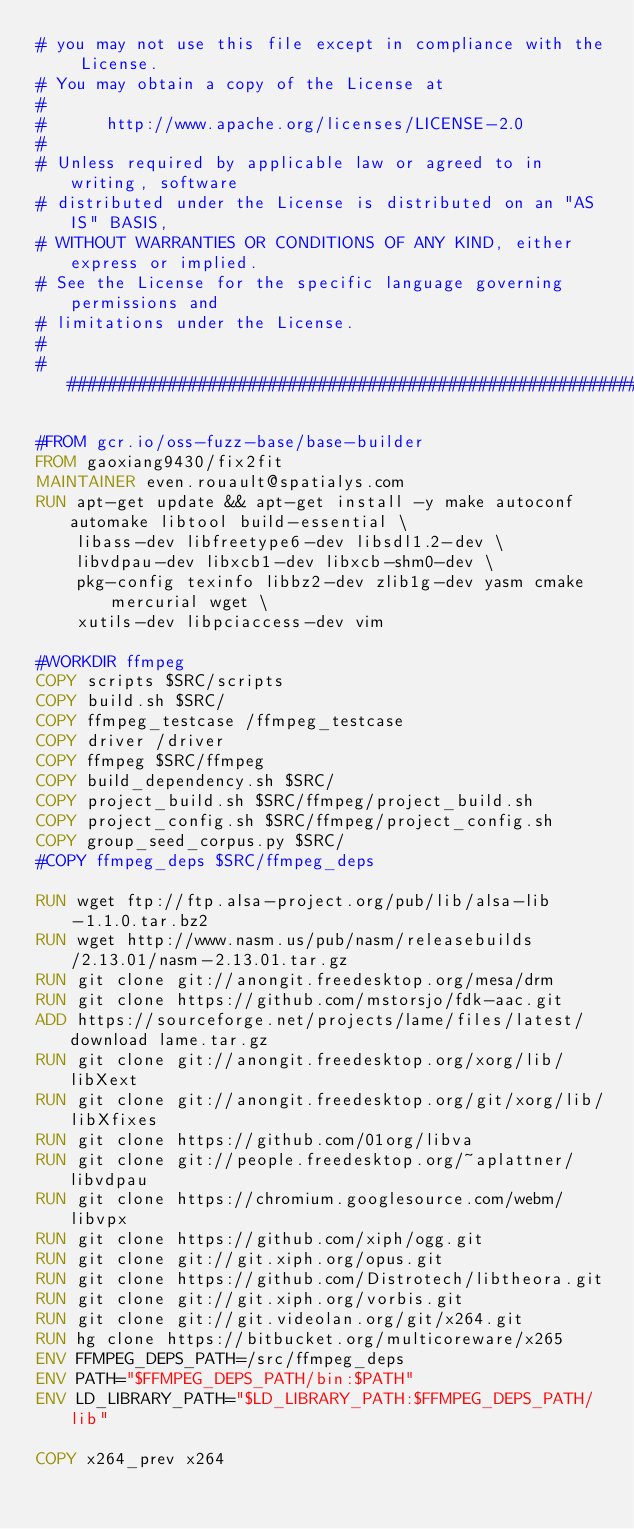Convert code to text. <code><loc_0><loc_0><loc_500><loc_500><_Dockerfile_># you may not use this file except in compliance with the License.
# You may obtain a copy of the License at
#
#      http://www.apache.org/licenses/LICENSE-2.0
#
# Unless required by applicable law or agreed to in writing, software
# distributed under the License is distributed on an "AS IS" BASIS,
# WITHOUT WARRANTIES OR CONDITIONS OF ANY KIND, either express or implied.
# See the License for the specific language governing permissions and
# limitations under the License.
#
################################################################################

#FROM gcr.io/oss-fuzz-base/base-builder
FROM gaoxiang9430/fix2fit
MAINTAINER even.rouault@spatialys.com
RUN apt-get update && apt-get install -y make autoconf automake libtool build-essential \
    libass-dev libfreetype6-dev libsdl1.2-dev \
    libvdpau-dev libxcb1-dev libxcb-shm0-dev \
    pkg-config texinfo libbz2-dev zlib1g-dev yasm cmake mercurial wget \
    xutils-dev libpciaccess-dev vim

#WORKDIR ffmpeg
COPY scripts $SRC/scripts
COPY build.sh $SRC/
COPY ffmpeg_testcase /ffmpeg_testcase
COPY driver /driver
COPY ffmpeg $SRC/ffmpeg
COPY build_dependency.sh $SRC/
COPY project_build.sh $SRC/ffmpeg/project_build.sh
COPY project_config.sh $SRC/ffmpeg/project_config.sh
COPY group_seed_corpus.py $SRC/
#COPY ffmpeg_deps $SRC/ffmpeg_deps

RUN wget ftp://ftp.alsa-project.org/pub/lib/alsa-lib-1.1.0.tar.bz2
RUN wget http://www.nasm.us/pub/nasm/releasebuilds/2.13.01/nasm-2.13.01.tar.gz
RUN git clone git://anongit.freedesktop.org/mesa/drm
RUN git clone https://github.com/mstorsjo/fdk-aac.git
ADD https://sourceforge.net/projects/lame/files/latest/download lame.tar.gz
RUN git clone git://anongit.freedesktop.org/xorg/lib/libXext
RUN git clone git://anongit.freedesktop.org/git/xorg/lib/libXfixes
RUN git clone https://github.com/01org/libva
RUN git clone git://people.freedesktop.org/~aplattner/libvdpau
RUN git clone https://chromium.googlesource.com/webm/libvpx
RUN git clone https://github.com/xiph/ogg.git
RUN git clone git://git.xiph.org/opus.git
RUN git clone https://github.com/Distrotech/libtheora.git
RUN git clone git://git.xiph.org/vorbis.git
RUN git clone git://git.videolan.org/git/x264.git
RUN hg clone https://bitbucket.org/multicoreware/x265
ENV FFMPEG_DEPS_PATH=/src/ffmpeg_deps
ENV PATH="$FFMPEG_DEPS_PATH/bin:$PATH"
ENV LD_LIBRARY_PATH="$LD_LIBRARY_PATH:$FFMPEG_DEPS_PATH/lib"

COPY x264_prev x264
</code> 